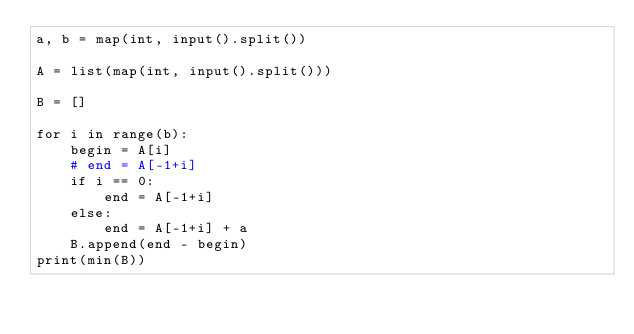Convert code to text. <code><loc_0><loc_0><loc_500><loc_500><_Python_>a, b = map(int, input().split())

A = list(map(int, input().split()))

B = []

for i in range(b):
    begin = A[i]
    # end = A[-1+i]
    if i == 0:
        end = A[-1+i]
    else:
        end = A[-1+i] + a
    B.append(end - begin)
print(min(B))</code> 